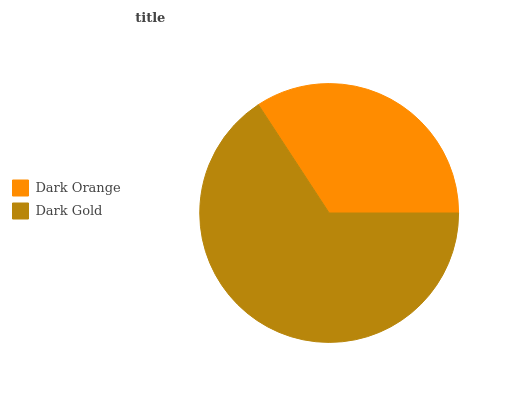Is Dark Orange the minimum?
Answer yes or no. Yes. Is Dark Gold the maximum?
Answer yes or no. Yes. Is Dark Gold the minimum?
Answer yes or no. No. Is Dark Gold greater than Dark Orange?
Answer yes or no. Yes. Is Dark Orange less than Dark Gold?
Answer yes or no. Yes. Is Dark Orange greater than Dark Gold?
Answer yes or no. No. Is Dark Gold less than Dark Orange?
Answer yes or no. No. Is Dark Gold the high median?
Answer yes or no. Yes. Is Dark Orange the low median?
Answer yes or no. Yes. Is Dark Orange the high median?
Answer yes or no. No. Is Dark Gold the low median?
Answer yes or no. No. 